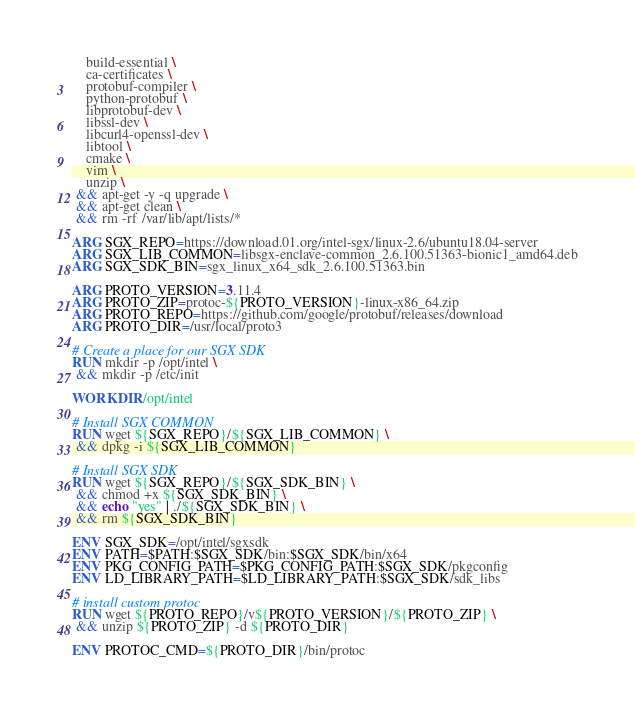Convert code to text. <code><loc_0><loc_0><loc_500><loc_500><_Dockerfile_>    build-essential \
    ca-certificates \
    protobuf-compiler \
    python-protobuf \
    libprotobuf-dev \
    libssl-dev \
    libcurl4-openssl-dev \
    libtool \
    cmake \
    vim \
    unzip \
 && apt-get -y -q upgrade \
 && apt-get clean \
 && rm -rf /var/lib/apt/lists/*

ARG SGX_REPO=https://download.01.org/intel-sgx/linux-2.6/ubuntu18.04-server
ARG SGX_LIB_COMMON=libsgx-enclave-common_2.6.100.51363-bionic1_amd64.deb
ARG SGX_SDK_BIN=sgx_linux_x64_sdk_2.6.100.51363.bin

ARG PROTO_VERSION=3.11.4
ARG PROTO_ZIP=protoc-${PROTO_VERSION}-linux-x86_64.zip
ARG PROTO_REPO=https://github.com/google/protobuf/releases/download
ARG PROTO_DIR=/usr/local/proto3

# Create a place for our SGX SDK
RUN mkdir -p /opt/intel \
 && mkdir -p /etc/init

WORKDIR /opt/intel

# Install SGX COMMON
RUN wget ${SGX_REPO}/${SGX_LIB_COMMON} \
 && dpkg -i ${SGX_LIB_COMMON}

# Install SGX SDK
RUN wget ${SGX_REPO}/${SGX_SDK_BIN} \
 && chmod +x ${SGX_SDK_BIN} \
 && echo "yes" | ./${SGX_SDK_BIN} \
 && rm ${SGX_SDK_BIN}

ENV SGX_SDK=/opt/intel/sgxsdk
ENV PATH=$PATH:$SGX_SDK/bin:$SGX_SDK/bin/x64
ENV PKG_CONFIG_PATH=$PKG_CONFIG_PATH:$SGX_SDK/pkgconfig
ENV LD_LIBRARY_PATH=$LD_LIBRARY_PATH:$SGX_SDK/sdk_libs

# install custom protoc
RUN wget ${PROTO_REPO}/v${PROTO_VERSION}/${PROTO_ZIP} \
 && unzip ${PROTO_ZIP} -d ${PROTO_DIR}

ENV PROTOC_CMD=${PROTO_DIR}/bin/protoc
</code> 